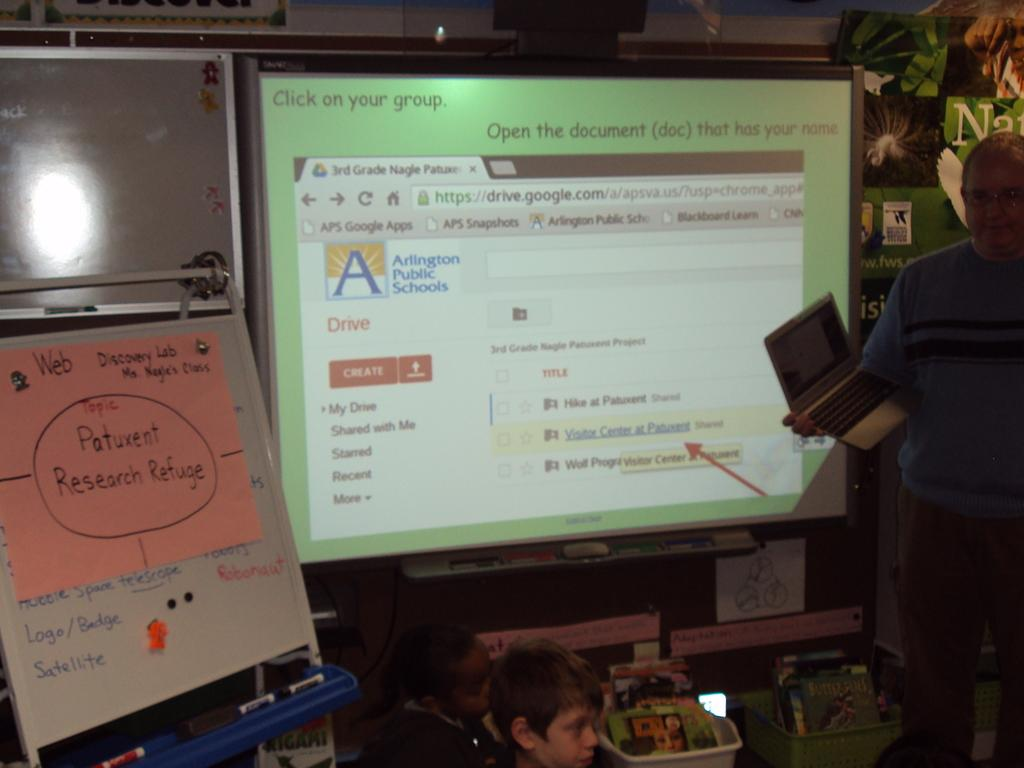<image>
Give a short and clear explanation of the subsequent image. A picture of Arlington Public Schools website projected on a large whiteboard. 